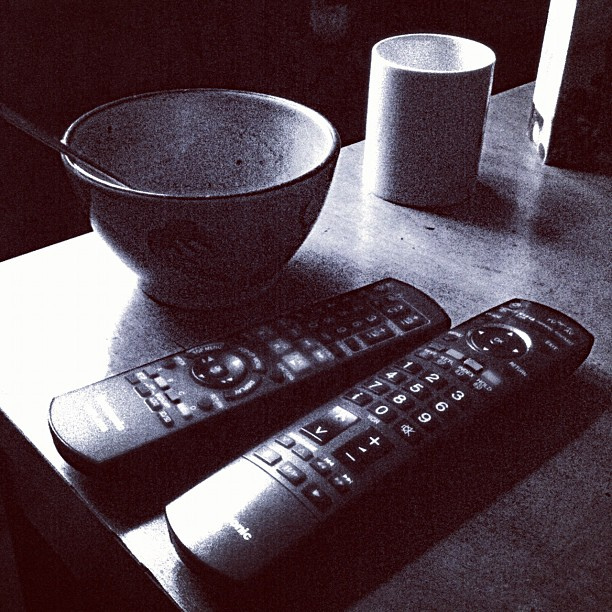Identify the text contained in this image. 0 8 9 6 5 7 4 1 2 3 